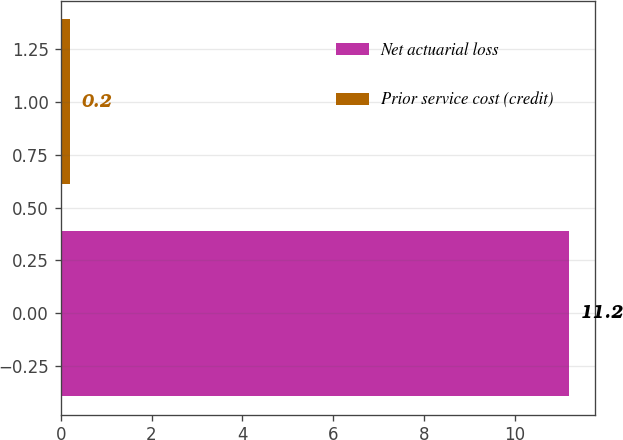Convert chart to OTSL. <chart><loc_0><loc_0><loc_500><loc_500><bar_chart><fcel>Net actuarial loss<fcel>Prior service cost (credit)<nl><fcel>11.2<fcel>0.2<nl></chart> 